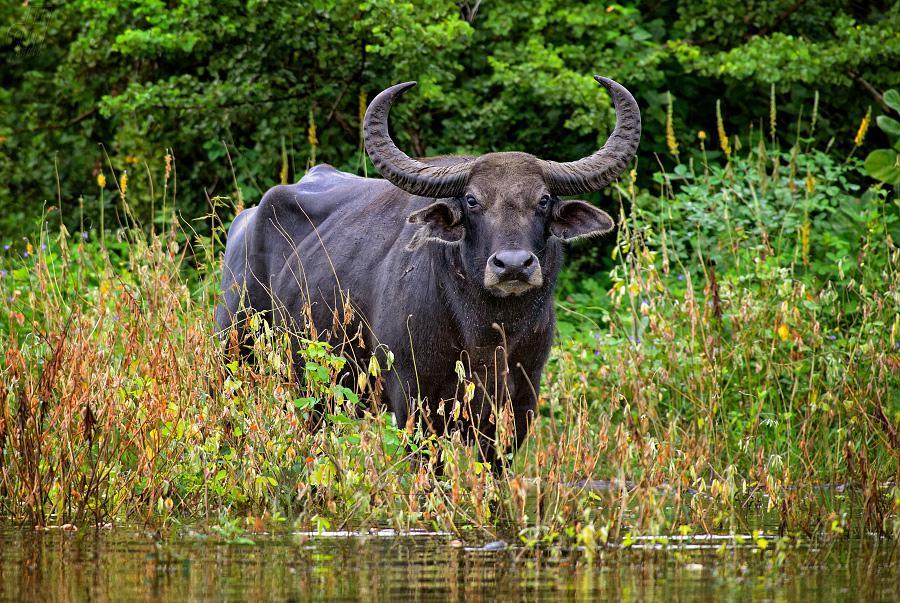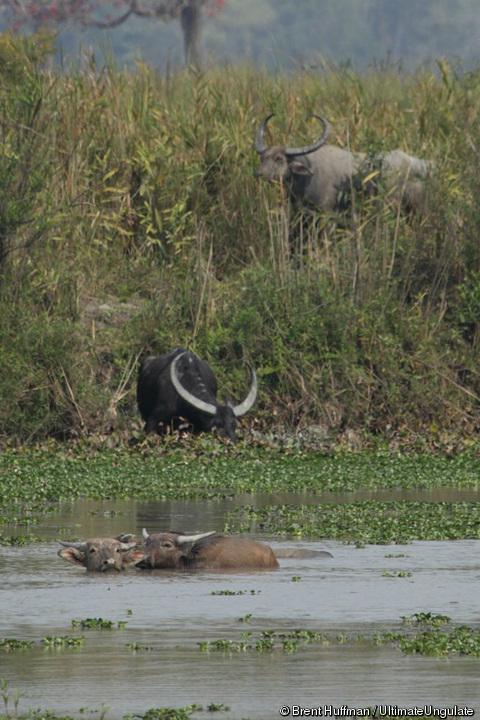The first image is the image on the left, the second image is the image on the right. For the images displayed, is the sentence "The right image contains exactly one water buffalo." factually correct? Answer yes or no. No. The first image is the image on the left, the second image is the image on the right. Given the left and right images, does the statement "At least 2 cows are standing in the water." hold true? Answer yes or no. Yes. 